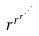Convert formula to latex. <formula><loc_0><loc_0><loc_500><loc_500>r ^ { r ^ { r ^ { \cdot ^ { \cdot ^ { \cdot } } } } }</formula> 